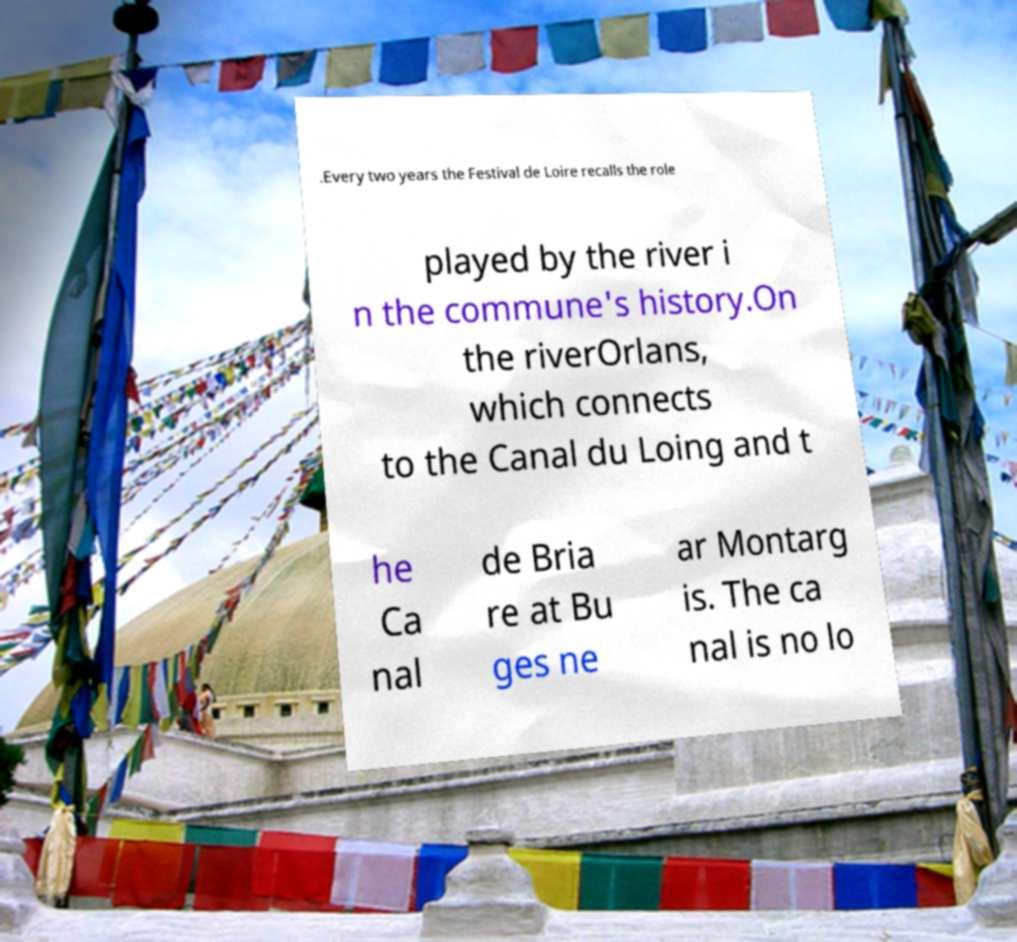I need the written content from this picture converted into text. Can you do that? .Every two years the Festival de Loire recalls the role played by the river i n the commune's history.On the riverOrlans, which connects to the Canal du Loing and t he Ca nal de Bria re at Bu ges ne ar Montarg is. The ca nal is no lo 